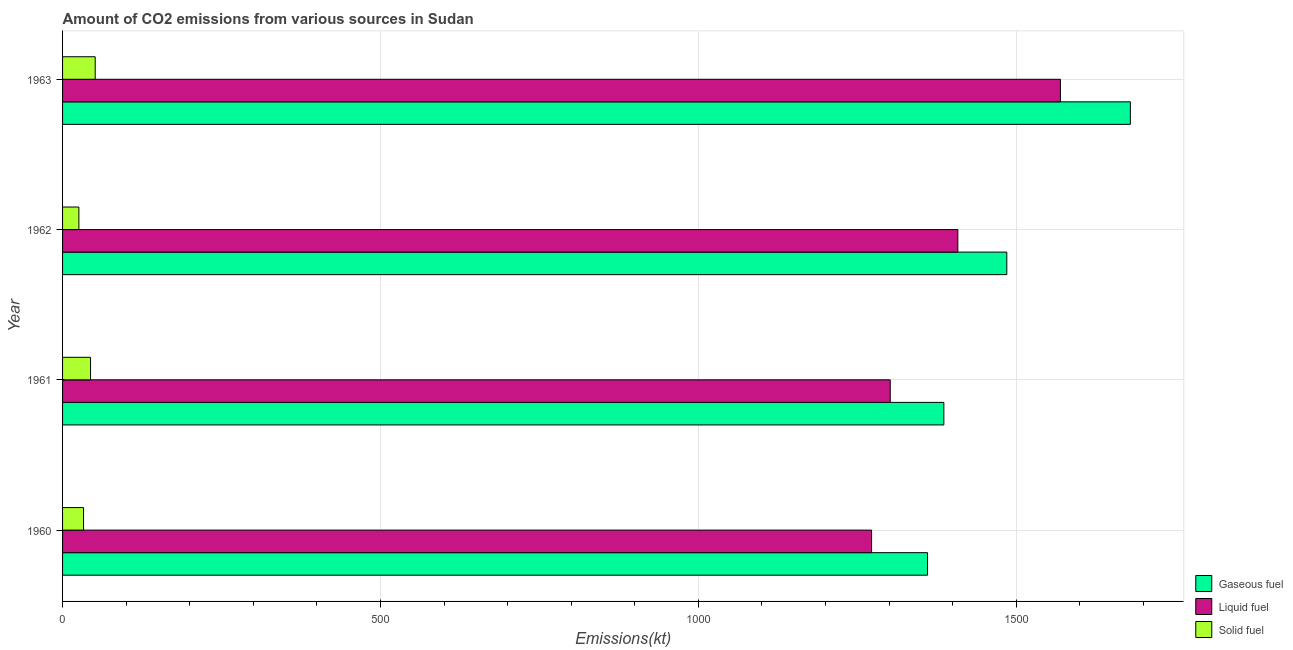How many different coloured bars are there?
Your response must be concise. 3. How many groups of bars are there?
Make the answer very short. 4. Are the number of bars per tick equal to the number of legend labels?
Keep it short and to the point. Yes. Are the number of bars on each tick of the Y-axis equal?
Keep it short and to the point. Yes. How many bars are there on the 3rd tick from the top?
Your answer should be compact. 3. How many bars are there on the 2nd tick from the bottom?
Keep it short and to the point. 3. What is the label of the 4th group of bars from the top?
Make the answer very short. 1960. In how many cases, is the number of bars for a given year not equal to the number of legend labels?
Make the answer very short. 0. What is the amount of co2 emissions from gaseous fuel in 1962?
Ensure brevity in your answer.  1485.13. Across all years, what is the maximum amount of co2 emissions from gaseous fuel?
Your answer should be very brief. 1679.49. Across all years, what is the minimum amount of co2 emissions from gaseous fuel?
Keep it short and to the point. 1360.46. In which year was the amount of co2 emissions from gaseous fuel minimum?
Your response must be concise. 1960. What is the total amount of co2 emissions from liquid fuel in the graph?
Make the answer very short. 5551.84. What is the difference between the amount of co2 emissions from solid fuel in 1961 and that in 1963?
Keep it short and to the point. -7.33. What is the difference between the amount of co2 emissions from solid fuel in 1963 and the amount of co2 emissions from liquid fuel in 1961?
Give a very brief answer. -1250.45. What is the average amount of co2 emissions from liquid fuel per year?
Keep it short and to the point. 1387.96. In the year 1963, what is the difference between the amount of co2 emissions from liquid fuel and amount of co2 emissions from solid fuel?
Provide a succinct answer. 1518.14. In how many years, is the amount of co2 emissions from solid fuel greater than 1100 kt?
Ensure brevity in your answer.  0. What is the ratio of the amount of co2 emissions from solid fuel in 1961 to that in 1963?
Give a very brief answer. 0.86. What is the difference between the highest and the second highest amount of co2 emissions from solid fuel?
Make the answer very short. 7.33. What is the difference between the highest and the lowest amount of co2 emissions from solid fuel?
Ensure brevity in your answer.  25.67. Is the sum of the amount of co2 emissions from liquid fuel in 1960 and 1962 greater than the maximum amount of co2 emissions from solid fuel across all years?
Offer a very short reply. Yes. What does the 3rd bar from the top in 1963 represents?
Offer a very short reply. Gaseous fuel. What does the 2nd bar from the bottom in 1963 represents?
Offer a very short reply. Liquid fuel. Are all the bars in the graph horizontal?
Make the answer very short. Yes. How many years are there in the graph?
Keep it short and to the point. 4. What is the difference between two consecutive major ticks on the X-axis?
Offer a very short reply. 500. Does the graph contain any zero values?
Make the answer very short. No. Does the graph contain grids?
Provide a short and direct response. Yes. Where does the legend appear in the graph?
Keep it short and to the point. Bottom right. What is the title of the graph?
Provide a short and direct response. Amount of CO2 emissions from various sources in Sudan. Does "Manufactures" appear as one of the legend labels in the graph?
Make the answer very short. No. What is the label or title of the X-axis?
Offer a very short reply. Emissions(kt). What is the label or title of the Y-axis?
Provide a short and direct response. Year. What is the Emissions(kt) in Gaseous fuel in 1960?
Your response must be concise. 1360.46. What is the Emissions(kt) of Liquid fuel in 1960?
Your answer should be compact. 1272.45. What is the Emissions(kt) in Solid fuel in 1960?
Your answer should be very brief. 33. What is the Emissions(kt) in Gaseous fuel in 1961?
Offer a very short reply. 1386.13. What is the Emissions(kt) in Liquid fuel in 1961?
Give a very brief answer. 1301.79. What is the Emissions(kt) of Solid fuel in 1961?
Keep it short and to the point. 44. What is the Emissions(kt) of Gaseous fuel in 1962?
Provide a short and direct response. 1485.13. What is the Emissions(kt) of Liquid fuel in 1962?
Your answer should be compact. 1408.13. What is the Emissions(kt) of Solid fuel in 1962?
Provide a short and direct response. 25.67. What is the Emissions(kt) in Gaseous fuel in 1963?
Ensure brevity in your answer.  1679.49. What is the Emissions(kt) of Liquid fuel in 1963?
Offer a terse response. 1569.48. What is the Emissions(kt) of Solid fuel in 1963?
Your answer should be very brief. 51.34. Across all years, what is the maximum Emissions(kt) in Gaseous fuel?
Your answer should be compact. 1679.49. Across all years, what is the maximum Emissions(kt) in Liquid fuel?
Offer a very short reply. 1569.48. Across all years, what is the maximum Emissions(kt) in Solid fuel?
Give a very brief answer. 51.34. Across all years, what is the minimum Emissions(kt) in Gaseous fuel?
Provide a succinct answer. 1360.46. Across all years, what is the minimum Emissions(kt) of Liquid fuel?
Give a very brief answer. 1272.45. Across all years, what is the minimum Emissions(kt) in Solid fuel?
Provide a succinct answer. 25.67. What is the total Emissions(kt) in Gaseous fuel in the graph?
Offer a very short reply. 5911.2. What is the total Emissions(kt) in Liquid fuel in the graph?
Provide a succinct answer. 5551.84. What is the total Emissions(kt) in Solid fuel in the graph?
Provide a succinct answer. 154.01. What is the difference between the Emissions(kt) in Gaseous fuel in 1960 and that in 1961?
Your answer should be very brief. -25.67. What is the difference between the Emissions(kt) of Liquid fuel in 1960 and that in 1961?
Your response must be concise. -29.34. What is the difference between the Emissions(kt) of Solid fuel in 1960 and that in 1961?
Offer a terse response. -11. What is the difference between the Emissions(kt) in Gaseous fuel in 1960 and that in 1962?
Offer a terse response. -124.68. What is the difference between the Emissions(kt) in Liquid fuel in 1960 and that in 1962?
Keep it short and to the point. -135.68. What is the difference between the Emissions(kt) in Solid fuel in 1960 and that in 1962?
Your answer should be very brief. 7.33. What is the difference between the Emissions(kt) in Gaseous fuel in 1960 and that in 1963?
Your answer should be compact. -319.03. What is the difference between the Emissions(kt) in Liquid fuel in 1960 and that in 1963?
Your answer should be compact. -297.03. What is the difference between the Emissions(kt) in Solid fuel in 1960 and that in 1963?
Your response must be concise. -18.34. What is the difference between the Emissions(kt) in Gaseous fuel in 1961 and that in 1962?
Your answer should be compact. -99.01. What is the difference between the Emissions(kt) of Liquid fuel in 1961 and that in 1962?
Give a very brief answer. -106.34. What is the difference between the Emissions(kt) of Solid fuel in 1961 and that in 1962?
Offer a terse response. 18.34. What is the difference between the Emissions(kt) in Gaseous fuel in 1961 and that in 1963?
Your answer should be very brief. -293.36. What is the difference between the Emissions(kt) in Liquid fuel in 1961 and that in 1963?
Your answer should be compact. -267.69. What is the difference between the Emissions(kt) in Solid fuel in 1961 and that in 1963?
Provide a short and direct response. -7.33. What is the difference between the Emissions(kt) in Gaseous fuel in 1962 and that in 1963?
Your answer should be compact. -194.35. What is the difference between the Emissions(kt) in Liquid fuel in 1962 and that in 1963?
Keep it short and to the point. -161.35. What is the difference between the Emissions(kt) in Solid fuel in 1962 and that in 1963?
Your response must be concise. -25.67. What is the difference between the Emissions(kt) in Gaseous fuel in 1960 and the Emissions(kt) in Liquid fuel in 1961?
Offer a terse response. 58.67. What is the difference between the Emissions(kt) in Gaseous fuel in 1960 and the Emissions(kt) in Solid fuel in 1961?
Provide a succinct answer. 1316.45. What is the difference between the Emissions(kt) of Liquid fuel in 1960 and the Emissions(kt) of Solid fuel in 1961?
Provide a short and direct response. 1228.44. What is the difference between the Emissions(kt) in Gaseous fuel in 1960 and the Emissions(kt) in Liquid fuel in 1962?
Keep it short and to the point. -47.67. What is the difference between the Emissions(kt) of Gaseous fuel in 1960 and the Emissions(kt) of Solid fuel in 1962?
Ensure brevity in your answer.  1334.79. What is the difference between the Emissions(kt) in Liquid fuel in 1960 and the Emissions(kt) in Solid fuel in 1962?
Provide a short and direct response. 1246.78. What is the difference between the Emissions(kt) of Gaseous fuel in 1960 and the Emissions(kt) of Liquid fuel in 1963?
Keep it short and to the point. -209.02. What is the difference between the Emissions(kt) in Gaseous fuel in 1960 and the Emissions(kt) in Solid fuel in 1963?
Offer a very short reply. 1309.12. What is the difference between the Emissions(kt) in Liquid fuel in 1960 and the Emissions(kt) in Solid fuel in 1963?
Give a very brief answer. 1221.11. What is the difference between the Emissions(kt) in Gaseous fuel in 1961 and the Emissions(kt) in Liquid fuel in 1962?
Give a very brief answer. -22. What is the difference between the Emissions(kt) of Gaseous fuel in 1961 and the Emissions(kt) of Solid fuel in 1962?
Keep it short and to the point. 1360.46. What is the difference between the Emissions(kt) of Liquid fuel in 1961 and the Emissions(kt) of Solid fuel in 1962?
Offer a very short reply. 1276.12. What is the difference between the Emissions(kt) in Gaseous fuel in 1961 and the Emissions(kt) in Liquid fuel in 1963?
Offer a very short reply. -183.35. What is the difference between the Emissions(kt) of Gaseous fuel in 1961 and the Emissions(kt) of Solid fuel in 1963?
Offer a very short reply. 1334.79. What is the difference between the Emissions(kt) in Liquid fuel in 1961 and the Emissions(kt) in Solid fuel in 1963?
Offer a very short reply. 1250.45. What is the difference between the Emissions(kt) in Gaseous fuel in 1962 and the Emissions(kt) in Liquid fuel in 1963?
Your answer should be very brief. -84.34. What is the difference between the Emissions(kt) in Gaseous fuel in 1962 and the Emissions(kt) in Solid fuel in 1963?
Offer a very short reply. 1433.8. What is the difference between the Emissions(kt) in Liquid fuel in 1962 and the Emissions(kt) in Solid fuel in 1963?
Give a very brief answer. 1356.79. What is the average Emissions(kt) in Gaseous fuel per year?
Your answer should be very brief. 1477.8. What is the average Emissions(kt) in Liquid fuel per year?
Offer a terse response. 1387.96. What is the average Emissions(kt) in Solid fuel per year?
Keep it short and to the point. 38.5. In the year 1960, what is the difference between the Emissions(kt) of Gaseous fuel and Emissions(kt) of Liquid fuel?
Provide a succinct answer. 88.01. In the year 1960, what is the difference between the Emissions(kt) in Gaseous fuel and Emissions(kt) in Solid fuel?
Make the answer very short. 1327.45. In the year 1960, what is the difference between the Emissions(kt) in Liquid fuel and Emissions(kt) in Solid fuel?
Your answer should be very brief. 1239.45. In the year 1961, what is the difference between the Emissions(kt) of Gaseous fuel and Emissions(kt) of Liquid fuel?
Offer a very short reply. 84.34. In the year 1961, what is the difference between the Emissions(kt) of Gaseous fuel and Emissions(kt) of Solid fuel?
Make the answer very short. 1342.12. In the year 1961, what is the difference between the Emissions(kt) in Liquid fuel and Emissions(kt) in Solid fuel?
Ensure brevity in your answer.  1257.78. In the year 1962, what is the difference between the Emissions(kt) in Gaseous fuel and Emissions(kt) in Liquid fuel?
Offer a very short reply. 77.01. In the year 1962, what is the difference between the Emissions(kt) in Gaseous fuel and Emissions(kt) in Solid fuel?
Provide a succinct answer. 1459.47. In the year 1962, what is the difference between the Emissions(kt) of Liquid fuel and Emissions(kt) of Solid fuel?
Your answer should be compact. 1382.46. In the year 1963, what is the difference between the Emissions(kt) of Gaseous fuel and Emissions(kt) of Liquid fuel?
Offer a terse response. 110.01. In the year 1963, what is the difference between the Emissions(kt) in Gaseous fuel and Emissions(kt) in Solid fuel?
Your answer should be very brief. 1628.15. In the year 1963, what is the difference between the Emissions(kt) in Liquid fuel and Emissions(kt) in Solid fuel?
Provide a short and direct response. 1518.14. What is the ratio of the Emissions(kt) in Gaseous fuel in 1960 to that in 1961?
Give a very brief answer. 0.98. What is the ratio of the Emissions(kt) in Liquid fuel in 1960 to that in 1961?
Your response must be concise. 0.98. What is the ratio of the Emissions(kt) in Solid fuel in 1960 to that in 1961?
Ensure brevity in your answer.  0.75. What is the ratio of the Emissions(kt) of Gaseous fuel in 1960 to that in 1962?
Offer a terse response. 0.92. What is the ratio of the Emissions(kt) in Liquid fuel in 1960 to that in 1962?
Your response must be concise. 0.9. What is the ratio of the Emissions(kt) in Solid fuel in 1960 to that in 1962?
Provide a succinct answer. 1.29. What is the ratio of the Emissions(kt) of Gaseous fuel in 1960 to that in 1963?
Keep it short and to the point. 0.81. What is the ratio of the Emissions(kt) in Liquid fuel in 1960 to that in 1963?
Your response must be concise. 0.81. What is the ratio of the Emissions(kt) in Solid fuel in 1960 to that in 1963?
Provide a short and direct response. 0.64. What is the ratio of the Emissions(kt) of Gaseous fuel in 1961 to that in 1962?
Offer a terse response. 0.93. What is the ratio of the Emissions(kt) of Liquid fuel in 1961 to that in 1962?
Make the answer very short. 0.92. What is the ratio of the Emissions(kt) of Solid fuel in 1961 to that in 1962?
Give a very brief answer. 1.71. What is the ratio of the Emissions(kt) in Gaseous fuel in 1961 to that in 1963?
Your response must be concise. 0.83. What is the ratio of the Emissions(kt) of Liquid fuel in 1961 to that in 1963?
Make the answer very short. 0.83. What is the ratio of the Emissions(kt) in Solid fuel in 1961 to that in 1963?
Provide a short and direct response. 0.86. What is the ratio of the Emissions(kt) of Gaseous fuel in 1962 to that in 1963?
Make the answer very short. 0.88. What is the ratio of the Emissions(kt) of Liquid fuel in 1962 to that in 1963?
Your answer should be compact. 0.9. What is the ratio of the Emissions(kt) in Solid fuel in 1962 to that in 1963?
Your answer should be very brief. 0.5. What is the difference between the highest and the second highest Emissions(kt) in Gaseous fuel?
Your response must be concise. 194.35. What is the difference between the highest and the second highest Emissions(kt) in Liquid fuel?
Ensure brevity in your answer.  161.35. What is the difference between the highest and the second highest Emissions(kt) in Solid fuel?
Keep it short and to the point. 7.33. What is the difference between the highest and the lowest Emissions(kt) of Gaseous fuel?
Make the answer very short. 319.03. What is the difference between the highest and the lowest Emissions(kt) of Liquid fuel?
Offer a terse response. 297.03. What is the difference between the highest and the lowest Emissions(kt) in Solid fuel?
Provide a succinct answer. 25.67. 